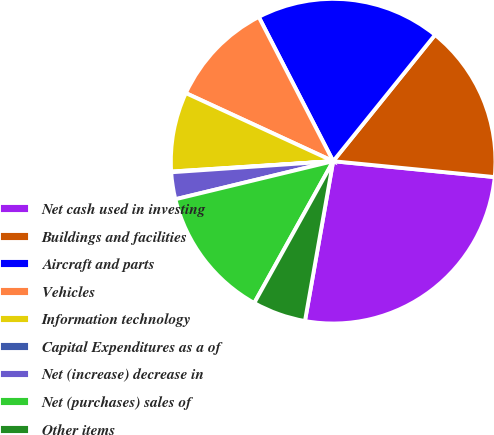Convert chart. <chart><loc_0><loc_0><loc_500><loc_500><pie_chart><fcel>Net cash used in investing<fcel>Buildings and facilities<fcel>Aircraft and parts<fcel>Vehicles<fcel>Information technology<fcel>Capital Expenditures as a of<fcel>Net (increase) decrease in<fcel>Net (purchases) sales of<fcel>Other items<nl><fcel>26.22%<fcel>15.76%<fcel>18.38%<fcel>10.53%<fcel>7.91%<fcel>0.07%<fcel>2.68%<fcel>13.15%<fcel>5.3%<nl></chart> 